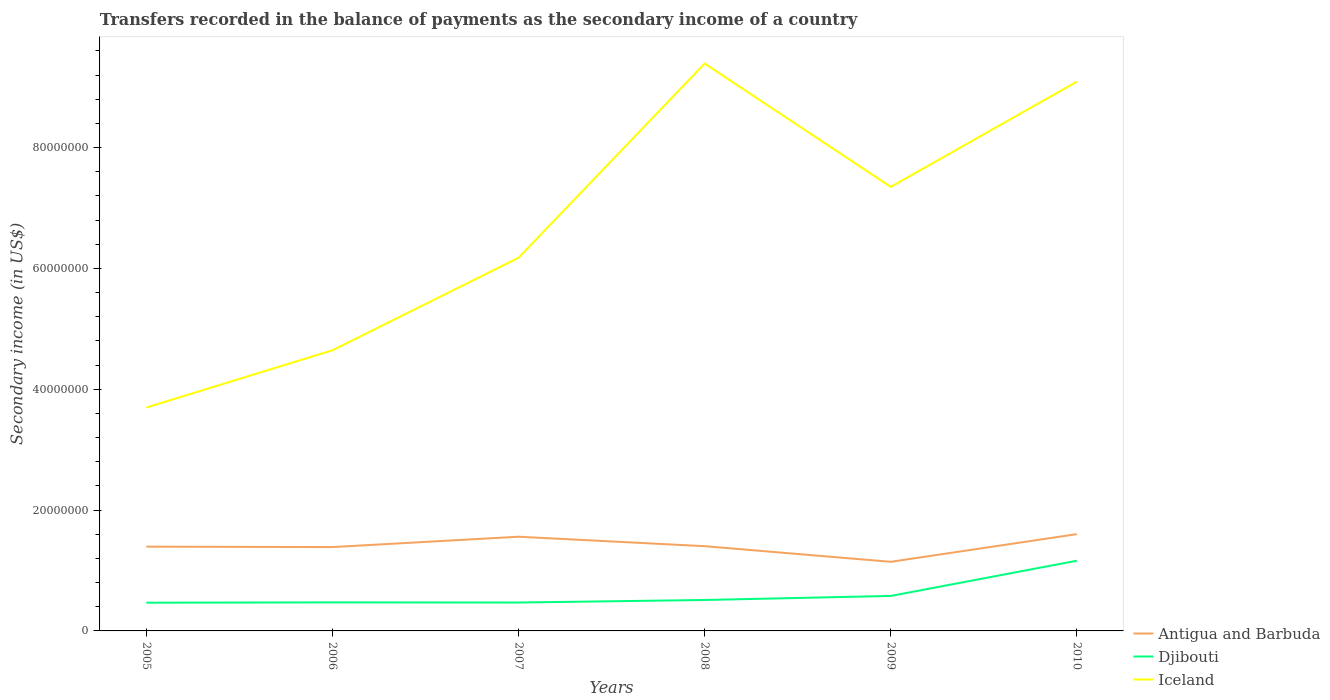How many different coloured lines are there?
Provide a short and direct response. 3. Is the number of lines equal to the number of legend labels?
Provide a short and direct response. Yes. Across all years, what is the maximum secondary income of in Antigua and Barbuda?
Your response must be concise. 1.14e+07. In which year was the secondary income of in Djibouti maximum?
Offer a terse response. 2005. What is the total secondary income of in Antigua and Barbuda in the graph?
Your answer should be compact. 4.15e+06. What is the difference between the highest and the second highest secondary income of in Iceland?
Your answer should be compact. 5.69e+07. Is the secondary income of in Iceland strictly greater than the secondary income of in Djibouti over the years?
Your response must be concise. No. How many years are there in the graph?
Make the answer very short. 6. What is the difference between two consecutive major ticks on the Y-axis?
Provide a succinct answer. 2.00e+07. Does the graph contain grids?
Your answer should be compact. No. How many legend labels are there?
Provide a short and direct response. 3. How are the legend labels stacked?
Provide a succinct answer. Vertical. What is the title of the graph?
Provide a short and direct response. Transfers recorded in the balance of payments as the secondary income of a country. What is the label or title of the Y-axis?
Ensure brevity in your answer.  Secondary income (in US$). What is the Secondary income (in US$) in Antigua and Barbuda in 2005?
Offer a terse response. 1.39e+07. What is the Secondary income (in US$) of Djibouti in 2005?
Your response must be concise. 4.67e+06. What is the Secondary income (in US$) of Iceland in 2005?
Ensure brevity in your answer.  3.70e+07. What is the Secondary income (in US$) in Antigua and Barbuda in 2006?
Make the answer very short. 1.39e+07. What is the Secondary income (in US$) of Djibouti in 2006?
Give a very brief answer. 4.73e+06. What is the Secondary income (in US$) in Iceland in 2006?
Offer a terse response. 4.65e+07. What is the Secondary income (in US$) of Antigua and Barbuda in 2007?
Offer a very short reply. 1.56e+07. What is the Secondary income (in US$) in Djibouti in 2007?
Offer a very short reply. 4.70e+06. What is the Secondary income (in US$) of Iceland in 2007?
Your answer should be very brief. 6.18e+07. What is the Secondary income (in US$) in Antigua and Barbuda in 2008?
Keep it short and to the point. 1.40e+07. What is the Secondary income (in US$) in Djibouti in 2008?
Your answer should be compact. 5.12e+06. What is the Secondary income (in US$) of Iceland in 2008?
Provide a short and direct response. 9.39e+07. What is the Secondary income (in US$) of Antigua and Barbuda in 2009?
Your answer should be compact. 1.14e+07. What is the Secondary income (in US$) of Djibouti in 2009?
Make the answer very short. 5.79e+06. What is the Secondary income (in US$) in Iceland in 2009?
Make the answer very short. 7.35e+07. What is the Secondary income (in US$) of Antigua and Barbuda in 2010?
Your response must be concise. 1.60e+07. What is the Secondary income (in US$) in Djibouti in 2010?
Offer a very short reply. 1.16e+07. What is the Secondary income (in US$) of Iceland in 2010?
Ensure brevity in your answer.  9.09e+07. Across all years, what is the maximum Secondary income (in US$) in Antigua and Barbuda?
Ensure brevity in your answer.  1.60e+07. Across all years, what is the maximum Secondary income (in US$) of Djibouti?
Your answer should be compact. 1.16e+07. Across all years, what is the maximum Secondary income (in US$) of Iceland?
Provide a succinct answer. 9.39e+07. Across all years, what is the minimum Secondary income (in US$) in Antigua and Barbuda?
Give a very brief answer. 1.14e+07. Across all years, what is the minimum Secondary income (in US$) of Djibouti?
Ensure brevity in your answer.  4.67e+06. Across all years, what is the minimum Secondary income (in US$) of Iceland?
Offer a very short reply. 3.70e+07. What is the total Secondary income (in US$) of Antigua and Barbuda in the graph?
Provide a succinct answer. 8.49e+07. What is the total Secondary income (in US$) in Djibouti in the graph?
Offer a very short reply. 3.66e+07. What is the total Secondary income (in US$) in Iceland in the graph?
Your answer should be compact. 4.04e+08. What is the difference between the Secondary income (in US$) of Antigua and Barbuda in 2005 and that in 2006?
Give a very brief answer. 6.84e+04. What is the difference between the Secondary income (in US$) of Djibouti in 2005 and that in 2006?
Provide a short and direct response. -5.63e+04. What is the difference between the Secondary income (in US$) of Iceland in 2005 and that in 2006?
Offer a terse response. -9.48e+06. What is the difference between the Secondary income (in US$) of Antigua and Barbuda in 2005 and that in 2007?
Keep it short and to the point. -1.65e+06. What is the difference between the Secondary income (in US$) in Djibouti in 2005 and that in 2007?
Ensure brevity in your answer.  -2.81e+04. What is the difference between the Secondary income (in US$) of Iceland in 2005 and that in 2007?
Your answer should be compact. -2.48e+07. What is the difference between the Secondary income (in US$) in Antigua and Barbuda in 2005 and that in 2008?
Provide a succinct answer. -7.86e+04. What is the difference between the Secondary income (in US$) of Djibouti in 2005 and that in 2008?
Your answer should be compact. -4.50e+05. What is the difference between the Secondary income (in US$) of Iceland in 2005 and that in 2008?
Your answer should be very brief. -5.69e+07. What is the difference between the Secondary income (in US$) of Antigua and Barbuda in 2005 and that in 2009?
Keep it short and to the point. 2.51e+06. What is the difference between the Secondary income (in US$) in Djibouti in 2005 and that in 2009?
Your response must be concise. -1.12e+06. What is the difference between the Secondary income (in US$) in Iceland in 2005 and that in 2009?
Ensure brevity in your answer.  -3.65e+07. What is the difference between the Secondary income (in US$) in Antigua and Barbuda in 2005 and that in 2010?
Offer a very short reply. -2.07e+06. What is the difference between the Secondary income (in US$) in Djibouti in 2005 and that in 2010?
Offer a terse response. -6.95e+06. What is the difference between the Secondary income (in US$) of Iceland in 2005 and that in 2010?
Offer a terse response. -5.39e+07. What is the difference between the Secondary income (in US$) in Antigua and Barbuda in 2006 and that in 2007?
Ensure brevity in your answer.  -1.71e+06. What is the difference between the Secondary income (in US$) in Djibouti in 2006 and that in 2007?
Provide a succinct answer. 2.81e+04. What is the difference between the Secondary income (in US$) in Iceland in 2006 and that in 2007?
Offer a terse response. -1.53e+07. What is the difference between the Secondary income (in US$) of Antigua and Barbuda in 2006 and that in 2008?
Your response must be concise. -1.47e+05. What is the difference between the Secondary income (in US$) of Djibouti in 2006 and that in 2008?
Make the answer very short. -3.94e+05. What is the difference between the Secondary income (in US$) in Iceland in 2006 and that in 2008?
Provide a succinct answer. -4.75e+07. What is the difference between the Secondary income (in US$) in Antigua and Barbuda in 2006 and that in 2009?
Your response must be concise. 2.44e+06. What is the difference between the Secondary income (in US$) of Djibouti in 2006 and that in 2009?
Your answer should be compact. -1.06e+06. What is the difference between the Secondary income (in US$) of Iceland in 2006 and that in 2009?
Offer a very short reply. -2.70e+07. What is the difference between the Secondary income (in US$) of Antigua and Barbuda in 2006 and that in 2010?
Keep it short and to the point. -2.14e+06. What is the difference between the Secondary income (in US$) of Djibouti in 2006 and that in 2010?
Offer a very short reply. -6.89e+06. What is the difference between the Secondary income (in US$) of Iceland in 2006 and that in 2010?
Give a very brief answer. -4.45e+07. What is the difference between the Secondary income (in US$) in Antigua and Barbuda in 2007 and that in 2008?
Give a very brief answer. 1.57e+06. What is the difference between the Secondary income (in US$) in Djibouti in 2007 and that in 2008?
Ensure brevity in your answer.  -4.22e+05. What is the difference between the Secondary income (in US$) in Iceland in 2007 and that in 2008?
Provide a short and direct response. -3.22e+07. What is the difference between the Secondary income (in US$) in Antigua and Barbuda in 2007 and that in 2009?
Your answer should be very brief. 4.15e+06. What is the difference between the Secondary income (in US$) of Djibouti in 2007 and that in 2009?
Your answer should be very brief. -1.09e+06. What is the difference between the Secondary income (in US$) in Iceland in 2007 and that in 2009?
Provide a short and direct response. -1.17e+07. What is the difference between the Secondary income (in US$) in Antigua and Barbuda in 2007 and that in 2010?
Your answer should be very brief. -4.28e+05. What is the difference between the Secondary income (in US$) of Djibouti in 2007 and that in 2010?
Give a very brief answer. -6.92e+06. What is the difference between the Secondary income (in US$) in Iceland in 2007 and that in 2010?
Your response must be concise. -2.91e+07. What is the difference between the Secondary income (in US$) in Antigua and Barbuda in 2008 and that in 2009?
Make the answer very short. 2.59e+06. What is the difference between the Secondary income (in US$) in Djibouti in 2008 and that in 2009?
Your answer should be compact. -6.70e+05. What is the difference between the Secondary income (in US$) in Iceland in 2008 and that in 2009?
Your answer should be very brief. 2.04e+07. What is the difference between the Secondary income (in US$) in Antigua and Barbuda in 2008 and that in 2010?
Your response must be concise. -2.00e+06. What is the difference between the Secondary income (in US$) in Djibouti in 2008 and that in 2010?
Ensure brevity in your answer.  -6.50e+06. What is the difference between the Secondary income (in US$) of Iceland in 2008 and that in 2010?
Keep it short and to the point. 3.00e+06. What is the difference between the Secondary income (in US$) of Antigua and Barbuda in 2009 and that in 2010?
Give a very brief answer. -4.58e+06. What is the difference between the Secondary income (in US$) in Djibouti in 2009 and that in 2010?
Your response must be concise. -5.83e+06. What is the difference between the Secondary income (in US$) of Iceland in 2009 and that in 2010?
Offer a terse response. -1.74e+07. What is the difference between the Secondary income (in US$) in Antigua and Barbuda in 2005 and the Secondary income (in US$) in Djibouti in 2006?
Provide a succinct answer. 9.22e+06. What is the difference between the Secondary income (in US$) in Antigua and Barbuda in 2005 and the Secondary income (in US$) in Iceland in 2006?
Your answer should be compact. -3.25e+07. What is the difference between the Secondary income (in US$) of Djibouti in 2005 and the Secondary income (in US$) of Iceland in 2006?
Offer a terse response. -4.18e+07. What is the difference between the Secondary income (in US$) of Antigua and Barbuda in 2005 and the Secondary income (in US$) of Djibouti in 2007?
Keep it short and to the point. 9.25e+06. What is the difference between the Secondary income (in US$) of Antigua and Barbuda in 2005 and the Secondary income (in US$) of Iceland in 2007?
Your response must be concise. -4.78e+07. What is the difference between the Secondary income (in US$) in Djibouti in 2005 and the Secondary income (in US$) in Iceland in 2007?
Your answer should be very brief. -5.71e+07. What is the difference between the Secondary income (in US$) in Antigua and Barbuda in 2005 and the Secondary income (in US$) in Djibouti in 2008?
Your response must be concise. 8.83e+06. What is the difference between the Secondary income (in US$) in Antigua and Barbuda in 2005 and the Secondary income (in US$) in Iceland in 2008?
Give a very brief answer. -8.00e+07. What is the difference between the Secondary income (in US$) in Djibouti in 2005 and the Secondary income (in US$) in Iceland in 2008?
Your answer should be very brief. -8.93e+07. What is the difference between the Secondary income (in US$) of Antigua and Barbuda in 2005 and the Secondary income (in US$) of Djibouti in 2009?
Give a very brief answer. 8.16e+06. What is the difference between the Secondary income (in US$) in Antigua and Barbuda in 2005 and the Secondary income (in US$) in Iceland in 2009?
Your answer should be compact. -5.96e+07. What is the difference between the Secondary income (in US$) of Djibouti in 2005 and the Secondary income (in US$) of Iceland in 2009?
Keep it short and to the point. -6.88e+07. What is the difference between the Secondary income (in US$) in Antigua and Barbuda in 2005 and the Secondary income (in US$) in Djibouti in 2010?
Ensure brevity in your answer.  2.33e+06. What is the difference between the Secondary income (in US$) of Antigua and Barbuda in 2005 and the Secondary income (in US$) of Iceland in 2010?
Your answer should be very brief. -7.70e+07. What is the difference between the Secondary income (in US$) in Djibouti in 2005 and the Secondary income (in US$) in Iceland in 2010?
Give a very brief answer. -8.62e+07. What is the difference between the Secondary income (in US$) in Antigua and Barbuda in 2006 and the Secondary income (in US$) in Djibouti in 2007?
Ensure brevity in your answer.  9.18e+06. What is the difference between the Secondary income (in US$) of Antigua and Barbuda in 2006 and the Secondary income (in US$) of Iceland in 2007?
Your answer should be very brief. -4.79e+07. What is the difference between the Secondary income (in US$) in Djibouti in 2006 and the Secondary income (in US$) in Iceland in 2007?
Offer a very short reply. -5.70e+07. What is the difference between the Secondary income (in US$) of Antigua and Barbuda in 2006 and the Secondary income (in US$) of Djibouti in 2008?
Provide a short and direct response. 8.76e+06. What is the difference between the Secondary income (in US$) of Antigua and Barbuda in 2006 and the Secondary income (in US$) of Iceland in 2008?
Your answer should be compact. -8.00e+07. What is the difference between the Secondary income (in US$) of Djibouti in 2006 and the Secondary income (in US$) of Iceland in 2008?
Offer a terse response. -8.92e+07. What is the difference between the Secondary income (in US$) of Antigua and Barbuda in 2006 and the Secondary income (in US$) of Djibouti in 2009?
Your answer should be very brief. 8.09e+06. What is the difference between the Secondary income (in US$) of Antigua and Barbuda in 2006 and the Secondary income (in US$) of Iceland in 2009?
Your answer should be very brief. -5.96e+07. What is the difference between the Secondary income (in US$) of Djibouti in 2006 and the Secondary income (in US$) of Iceland in 2009?
Your answer should be compact. -6.88e+07. What is the difference between the Secondary income (in US$) in Antigua and Barbuda in 2006 and the Secondary income (in US$) in Djibouti in 2010?
Provide a short and direct response. 2.26e+06. What is the difference between the Secondary income (in US$) in Antigua and Barbuda in 2006 and the Secondary income (in US$) in Iceland in 2010?
Offer a very short reply. -7.70e+07. What is the difference between the Secondary income (in US$) in Djibouti in 2006 and the Secondary income (in US$) in Iceland in 2010?
Offer a terse response. -8.62e+07. What is the difference between the Secondary income (in US$) of Antigua and Barbuda in 2007 and the Secondary income (in US$) of Djibouti in 2008?
Offer a terse response. 1.05e+07. What is the difference between the Secondary income (in US$) of Antigua and Barbuda in 2007 and the Secondary income (in US$) of Iceland in 2008?
Your response must be concise. -7.83e+07. What is the difference between the Secondary income (in US$) of Djibouti in 2007 and the Secondary income (in US$) of Iceland in 2008?
Offer a terse response. -8.92e+07. What is the difference between the Secondary income (in US$) of Antigua and Barbuda in 2007 and the Secondary income (in US$) of Djibouti in 2009?
Your answer should be very brief. 9.80e+06. What is the difference between the Secondary income (in US$) of Antigua and Barbuda in 2007 and the Secondary income (in US$) of Iceland in 2009?
Provide a short and direct response. -5.79e+07. What is the difference between the Secondary income (in US$) of Djibouti in 2007 and the Secondary income (in US$) of Iceland in 2009?
Your answer should be compact. -6.88e+07. What is the difference between the Secondary income (in US$) in Antigua and Barbuda in 2007 and the Secondary income (in US$) in Djibouti in 2010?
Ensure brevity in your answer.  3.98e+06. What is the difference between the Secondary income (in US$) in Antigua and Barbuda in 2007 and the Secondary income (in US$) in Iceland in 2010?
Offer a very short reply. -7.53e+07. What is the difference between the Secondary income (in US$) in Djibouti in 2007 and the Secondary income (in US$) in Iceland in 2010?
Keep it short and to the point. -8.62e+07. What is the difference between the Secondary income (in US$) in Antigua and Barbuda in 2008 and the Secondary income (in US$) in Djibouti in 2009?
Provide a succinct answer. 8.24e+06. What is the difference between the Secondary income (in US$) of Antigua and Barbuda in 2008 and the Secondary income (in US$) of Iceland in 2009?
Keep it short and to the point. -5.95e+07. What is the difference between the Secondary income (in US$) of Djibouti in 2008 and the Secondary income (in US$) of Iceland in 2009?
Give a very brief answer. -6.84e+07. What is the difference between the Secondary income (in US$) of Antigua and Barbuda in 2008 and the Secondary income (in US$) of Djibouti in 2010?
Make the answer very short. 2.41e+06. What is the difference between the Secondary income (in US$) in Antigua and Barbuda in 2008 and the Secondary income (in US$) in Iceland in 2010?
Offer a very short reply. -7.69e+07. What is the difference between the Secondary income (in US$) in Djibouti in 2008 and the Secondary income (in US$) in Iceland in 2010?
Your answer should be compact. -8.58e+07. What is the difference between the Secondary income (in US$) in Antigua and Barbuda in 2009 and the Secondary income (in US$) in Djibouti in 2010?
Make the answer very short. -1.78e+05. What is the difference between the Secondary income (in US$) in Antigua and Barbuda in 2009 and the Secondary income (in US$) in Iceland in 2010?
Your response must be concise. -7.95e+07. What is the difference between the Secondary income (in US$) in Djibouti in 2009 and the Secondary income (in US$) in Iceland in 2010?
Provide a short and direct response. -8.51e+07. What is the average Secondary income (in US$) in Antigua and Barbuda per year?
Your answer should be very brief. 1.42e+07. What is the average Secondary income (in US$) in Djibouti per year?
Provide a succinct answer. 6.10e+06. What is the average Secondary income (in US$) in Iceland per year?
Ensure brevity in your answer.  6.73e+07. In the year 2005, what is the difference between the Secondary income (in US$) of Antigua and Barbuda and Secondary income (in US$) of Djibouti?
Provide a succinct answer. 9.28e+06. In the year 2005, what is the difference between the Secondary income (in US$) of Antigua and Barbuda and Secondary income (in US$) of Iceland?
Your response must be concise. -2.30e+07. In the year 2005, what is the difference between the Secondary income (in US$) of Djibouti and Secondary income (in US$) of Iceland?
Ensure brevity in your answer.  -3.23e+07. In the year 2006, what is the difference between the Secondary income (in US$) of Antigua and Barbuda and Secondary income (in US$) of Djibouti?
Ensure brevity in your answer.  9.15e+06. In the year 2006, what is the difference between the Secondary income (in US$) in Antigua and Barbuda and Secondary income (in US$) in Iceland?
Your answer should be very brief. -3.26e+07. In the year 2006, what is the difference between the Secondary income (in US$) in Djibouti and Secondary income (in US$) in Iceland?
Your response must be concise. -4.17e+07. In the year 2007, what is the difference between the Secondary income (in US$) of Antigua and Barbuda and Secondary income (in US$) of Djibouti?
Provide a short and direct response. 1.09e+07. In the year 2007, what is the difference between the Secondary income (in US$) of Antigua and Barbuda and Secondary income (in US$) of Iceland?
Your answer should be compact. -4.62e+07. In the year 2007, what is the difference between the Secondary income (in US$) of Djibouti and Secondary income (in US$) of Iceland?
Provide a succinct answer. -5.71e+07. In the year 2008, what is the difference between the Secondary income (in US$) in Antigua and Barbuda and Secondary income (in US$) in Djibouti?
Your answer should be compact. 8.91e+06. In the year 2008, what is the difference between the Secondary income (in US$) in Antigua and Barbuda and Secondary income (in US$) in Iceland?
Keep it short and to the point. -7.99e+07. In the year 2008, what is the difference between the Secondary income (in US$) of Djibouti and Secondary income (in US$) of Iceland?
Provide a short and direct response. -8.88e+07. In the year 2009, what is the difference between the Secondary income (in US$) in Antigua and Barbuda and Secondary income (in US$) in Djibouti?
Your answer should be compact. 5.65e+06. In the year 2009, what is the difference between the Secondary income (in US$) in Antigua and Barbuda and Secondary income (in US$) in Iceland?
Your answer should be compact. -6.21e+07. In the year 2009, what is the difference between the Secondary income (in US$) in Djibouti and Secondary income (in US$) in Iceland?
Make the answer very short. -6.77e+07. In the year 2010, what is the difference between the Secondary income (in US$) in Antigua and Barbuda and Secondary income (in US$) in Djibouti?
Provide a succinct answer. 4.40e+06. In the year 2010, what is the difference between the Secondary income (in US$) of Antigua and Barbuda and Secondary income (in US$) of Iceland?
Make the answer very short. -7.49e+07. In the year 2010, what is the difference between the Secondary income (in US$) of Djibouti and Secondary income (in US$) of Iceland?
Make the answer very short. -7.93e+07. What is the ratio of the Secondary income (in US$) in Antigua and Barbuda in 2005 to that in 2006?
Offer a terse response. 1. What is the ratio of the Secondary income (in US$) in Iceland in 2005 to that in 2006?
Provide a short and direct response. 0.8. What is the ratio of the Secondary income (in US$) in Antigua and Barbuda in 2005 to that in 2007?
Make the answer very short. 0.89. What is the ratio of the Secondary income (in US$) of Djibouti in 2005 to that in 2007?
Ensure brevity in your answer.  0.99. What is the ratio of the Secondary income (in US$) of Iceland in 2005 to that in 2007?
Make the answer very short. 0.6. What is the ratio of the Secondary income (in US$) in Djibouti in 2005 to that in 2008?
Your answer should be very brief. 0.91. What is the ratio of the Secondary income (in US$) in Iceland in 2005 to that in 2008?
Ensure brevity in your answer.  0.39. What is the ratio of the Secondary income (in US$) in Antigua and Barbuda in 2005 to that in 2009?
Ensure brevity in your answer.  1.22. What is the ratio of the Secondary income (in US$) in Djibouti in 2005 to that in 2009?
Offer a very short reply. 0.81. What is the ratio of the Secondary income (in US$) of Iceland in 2005 to that in 2009?
Your answer should be very brief. 0.5. What is the ratio of the Secondary income (in US$) in Antigua and Barbuda in 2005 to that in 2010?
Provide a short and direct response. 0.87. What is the ratio of the Secondary income (in US$) in Djibouti in 2005 to that in 2010?
Ensure brevity in your answer.  0.4. What is the ratio of the Secondary income (in US$) of Iceland in 2005 to that in 2010?
Your response must be concise. 0.41. What is the ratio of the Secondary income (in US$) of Antigua and Barbuda in 2006 to that in 2007?
Your answer should be compact. 0.89. What is the ratio of the Secondary income (in US$) of Iceland in 2006 to that in 2007?
Your answer should be very brief. 0.75. What is the ratio of the Secondary income (in US$) of Antigua and Barbuda in 2006 to that in 2008?
Offer a very short reply. 0.99. What is the ratio of the Secondary income (in US$) in Iceland in 2006 to that in 2008?
Offer a terse response. 0.49. What is the ratio of the Secondary income (in US$) of Antigua and Barbuda in 2006 to that in 2009?
Offer a terse response. 1.21. What is the ratio of the Secondary income (in US$) in Djibouti in 2006 to that in 2009?
Give a very brief answer. 0.82. What is the ratio of the Secondary income (in US$) of Iceland in 2006 to that in 2009?
Your answer should be compact. 0.63. What is the ratio of the Secondary income (in US$) of Antigua and Barbuda in 2006 to that in 2010?
Provide a succinct answer. 0.87. What is the ratio of the Secondary income (in US$) of Djibouti in 2006 to that in 2010?
Offer a terse response. 0.41. What is the ratio of the Secondary income (in US$) of Iceland in 2006 to that in 2010?
Keep it short and to the point. 0.51. What is the ratio of the Secondary income (in US$) of Antigua and Barbuda in 2007 to that in 2008?
Make the answer very short. 1.11. What is the ratio of the Secondary income (in US$) of Djibouti in 2007 to that in 2008?
Ensure brevity in your answer.  0.92. What is the ratio of the Secondary income (in US$) in Iceland in 2007 to that in 2008?
Your response must be concise. 0.66. What is the ratio of the Secondary income (in US$) in Antigua and Barbuda in 2007 to that in 2009?
Provide a succinct answer. 1.36. What is the ratio of the Secondary income (in US$) of Djibouti in 2007 to that in 2009?
Offer a very short reply. 0.81. What is the ratio of the Secondary income (in US$) in Iceland in 2007 to that in 2009?
Your response must be concise. 0.84. What is the ratio of the Secondary income (in US$) in Antigua and Barbuda in 2007 to that in 2010?
Make the answer very short. 0.97. What is the ratio of the Secondary income (in US$) of Djibouti in 2007 to that in 2010?
Your answer should be very brief. 0.4. What is the ratio of the Secondary income (in US$) of Iceland in 2007 to that in 2010?
Keep it short and to the point. 0.68. What is the ratio of the Secondary income (in US$) of Antigua and Barbuda in 2008 to that in 2009?
Provide a succinct answer. 1.23. What is the ratio of the Secondary income (in US$) of Djibouti in 2008 to that in 2009?
Give a very brief answer. 0.88. What is the ratio of the Secondary income (in US$) in Iceland in 2008 to that in 2009?
Provide a succinct answer. 1.28. What is the ratio of the Secondary income (in US$) in Antigua and Barbuda in 2008 to that in 2010?
Provide a short and direct response. 0.88. What is the ratio of the Secondary income (in US$) of Djibouti in 2008 to that in 2010?
Offer a terse response. 0.44. What is the ratio of the Secondary income (in US$) of Iceland in 2008 to that in 2010?
Offer a very short reply. 1.03. What is the ratio of the Secondary income (in US$) of Antigua and Barbuda in 2009 to that in 2010?
Your answer should be compact. 0.71. What is the ratio of the Secondary income (in US$) in Djibouti in 2009 to that in 2010?
Give a very brief answer. 0.5. What is the ratio of the Secondary income (in US$) in Iceland in 2009 to that in 2010?
Provide a short and direct response. 0.81. What is the difference between the highest and the second highest Secondary income (in US$) of Antigua and Barbuda?
Your response must be concise. 4.28e+05. What is the difference between the highest and the second highest Secondary income (in US$) in Djibouti?
Your response must be concise. 5.83e+06. What is the difference between the highest and the second highest Secondary income (in US$) of Iceland?
Give a very brief answer. 3.00e+06. What is the difference between the highest and the lowest Secondary income (in US$) in Antigua and Barbuda?
Offer a very short reply. 4.58e+06. What is the difference between the highest and the lowest Secondary income (in US$) in Djibouti?
Ensure brevity in your answer.  6.95e+06. What is the difference between the highest and the lowest Secondary income (in US$) of Iceland?
Provide a succinct answer. 5.69e+07. 